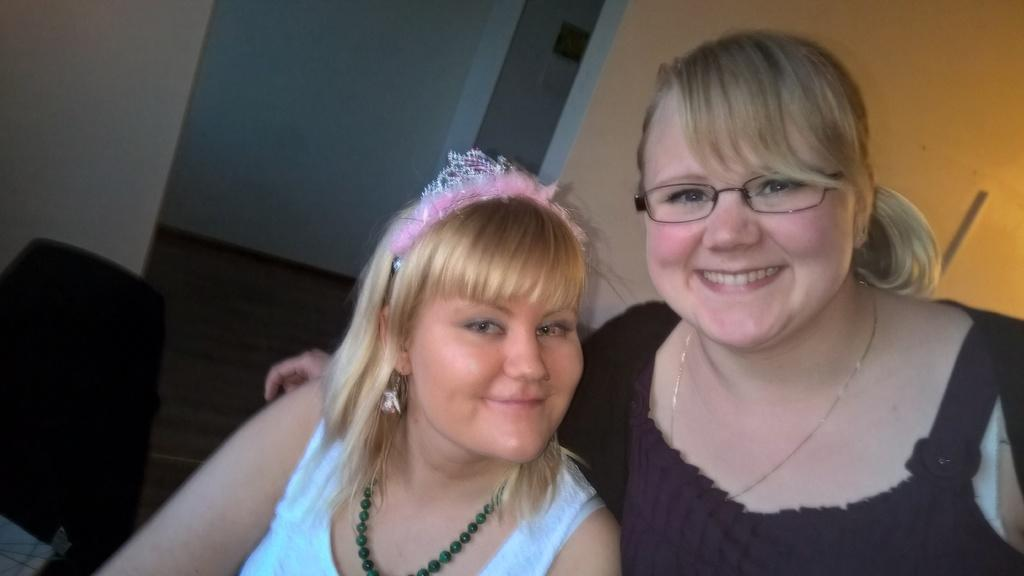How many people are in the image? There are two women in the image. What is the facial expression of the women? The women are smiling. What can be seen on the left side of the image? There is a chair on the left side of the image. What is visible in the background of the image? There are walls visible in the background of the image. What type of stem can be seen growing from the woman's hand in the image? There is no stem growing from the woman's hand in the image. How many birds are perched on the chair in the image? There are no birds present in the image. 